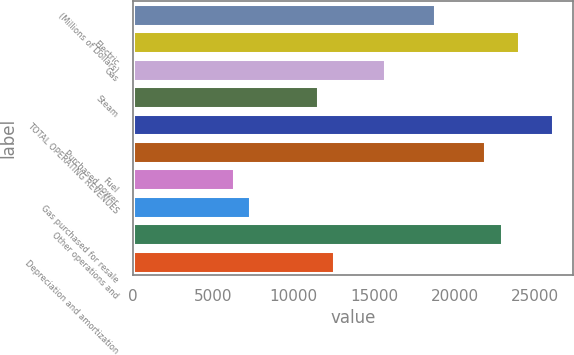Convert chart to OTSL. <chart><loc_0><loc_0><loc_500><loc_500><bar_chart><fcel>(Millions of Dollars)<fcel>Electric<fcel>Gas<fcel>Steam<fcel>TOTAL OPERATING REVENUES<fcel>Purchased power<fcel>Fuel<fcel>Gas purchased for resale<fcel>Other operations and<fcel>Depreciation and amortization<nl><fcel>18776<fcel>23991<fcel>15647<fcel>11475<fcel>26077<fcel>21905<fcel>6260<fcel>7303<fcel>22948<fcel>12518<nl></chart> 